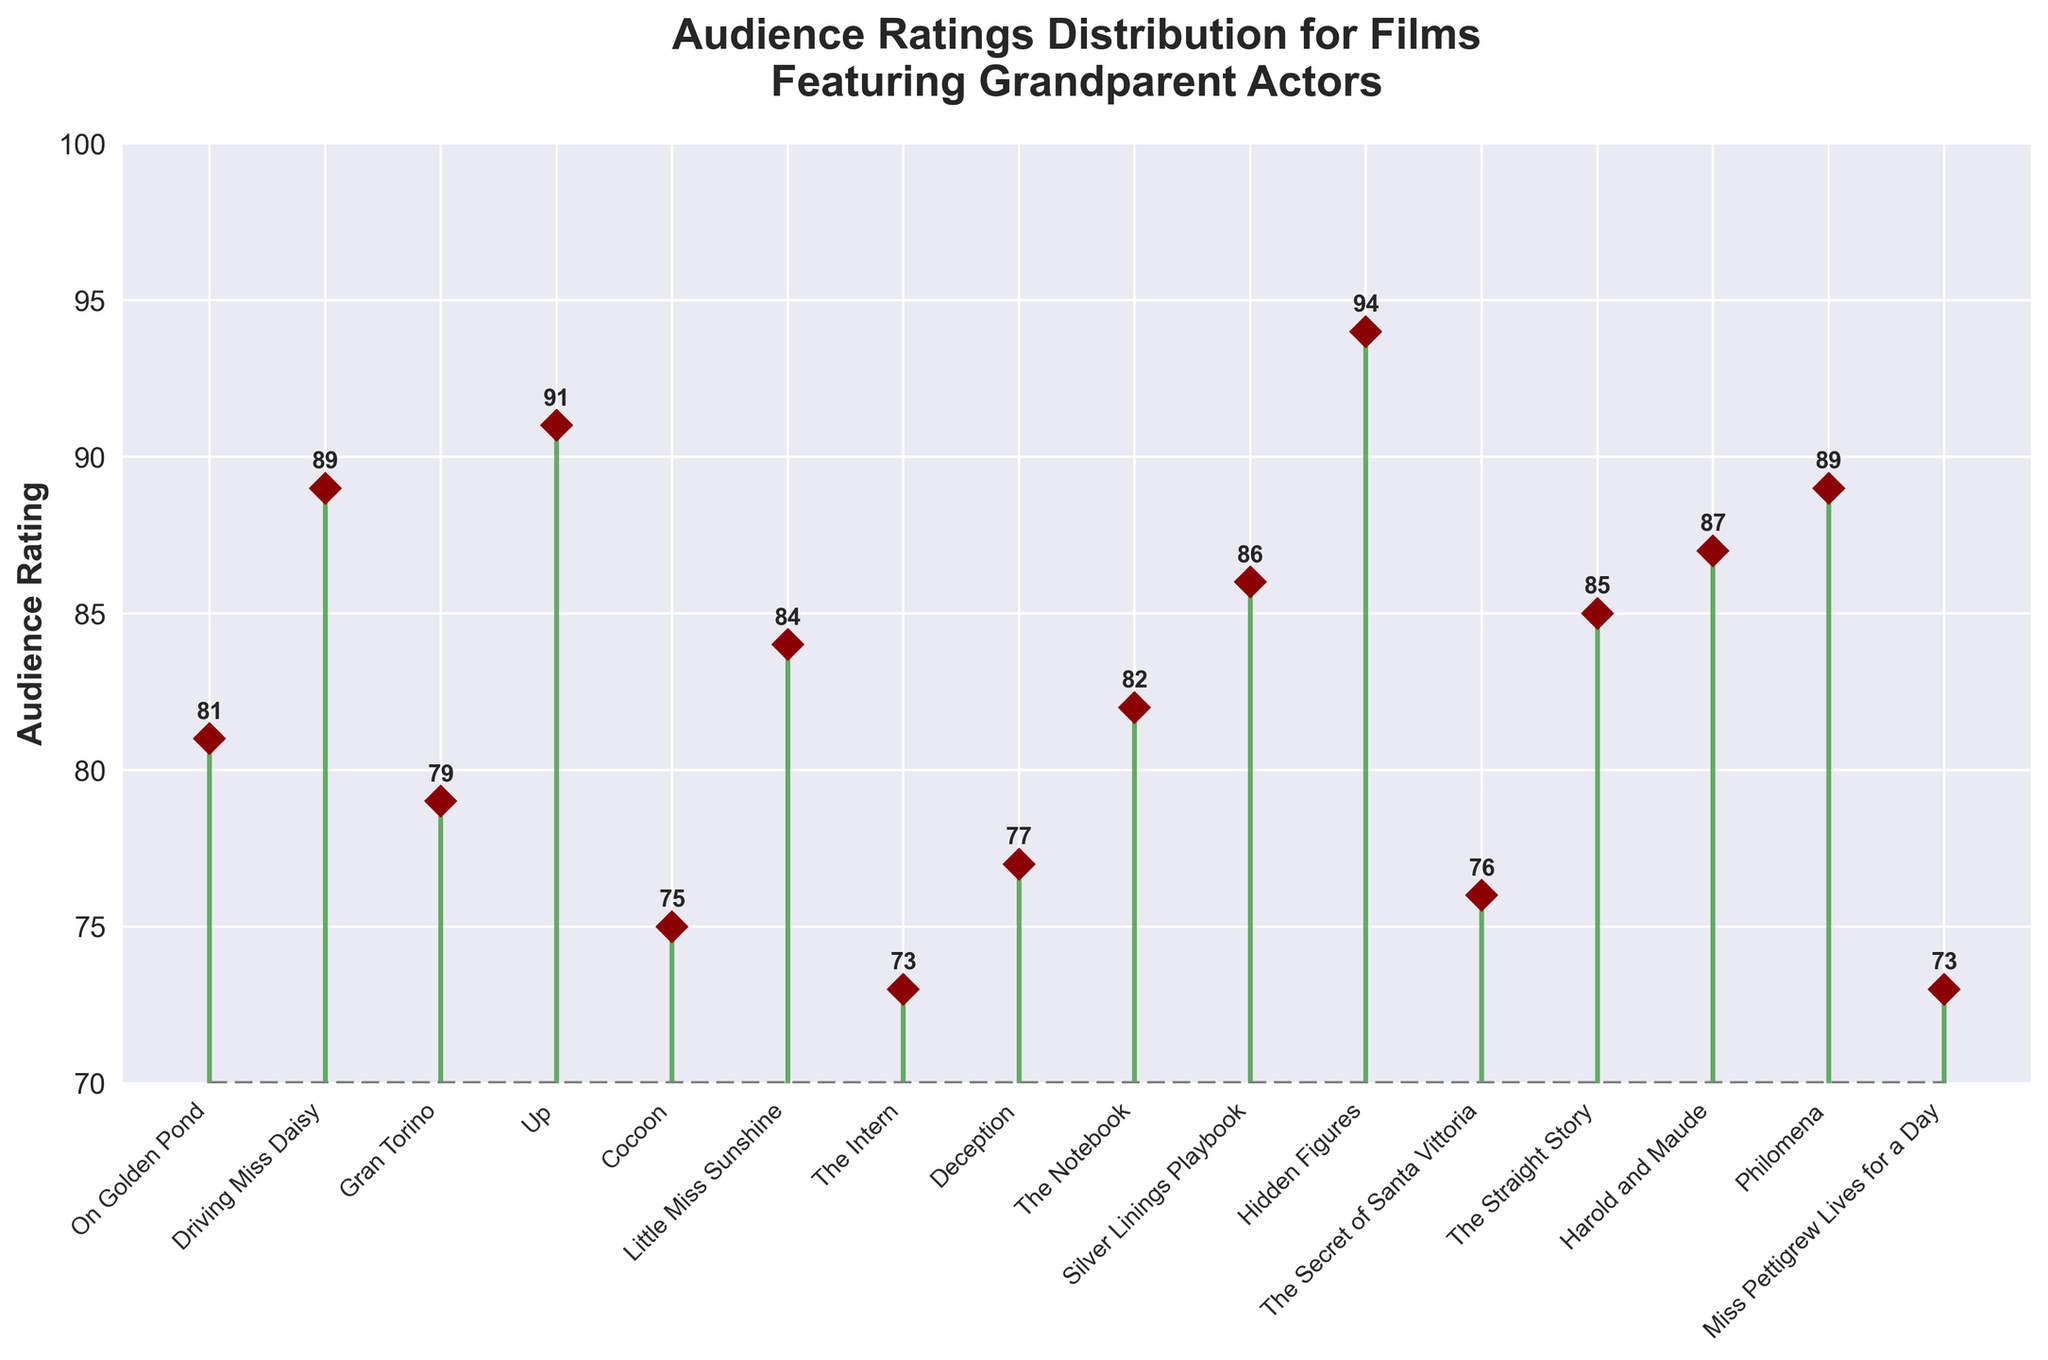What is the title of the plot? The title is displayed at the top of the plot, which reads "Audience Ratings Distribution for Films Featuring Grandparent Actors".
Answer: Audience Ratings Distribution for Films Featuring Grandparent Actors What does the y-axis represent? The label on the y-axis reads "Audience Rating", indicating that the y-axis represents the audience ratings of the films.
Answer: Audience Rating How many movies are depicted on the plot? The stem plot has markers corresponding to each movie title on the x-axis. Counting these titles gives 16 movies.
Answer: 16 Which film has the highest audience rating? From the stem plot, the film "Hidden Figures" has the highest marker point on the y-axis, indicating the highest audience rating of 94.
Answer: Hidden Figures What is the rating of the movie "Up"? The point corresponding to "Up" is located on the y-axis at 91, showing its audience rating.
Answer: 91 What is the average rating of all the movies depicted? First, sum the ratings of all movies: 81 + 89 + 79 + 91 + 75 + 84 + 73 + 77 + 82 + 86 + 94 + 76 + 85 + 87 + 89 + 73 = 1311. Then, divide by the number of movies, 1311 / 16 ≈ 81.94.
Answer: 81.94 Which movie has the lowest audience rating? From the plot, the movies "The Intern" and "Miss Pettigrew Lives for a Day" have the lowest markers at 73.
Answer: The Intern and Miss Pettigrew Lives for a Day How many movies have an audience rating greater than 85? From the plot, the movies with ratings above 85 are "Driving Miss Daisy", "Silver Linings Playbook", "Hidden Figures", "Harold and Maude", and "Philomena". Counting these gives 5 movies.
Answer: 5 What is the median audience rating of the movies? To find the median, list the ratings in ascending order: 73, 73, 75, 76, 77, 79, 81, 82, 84, 85, 86, 87, 89, 89, 91, 94. The median is the average of the 8th and 9th numbers: (82 + 84) / 2 = 83.
Answer: 83 Which two movies have the closest audience ratings? From the plot, "Deception" (77) and "The Secret of Santa Vittoria" (76) have audience ratings that are closest in value with a difference of 1.
Answer: Deception and The Secret of Santa Vittoria 